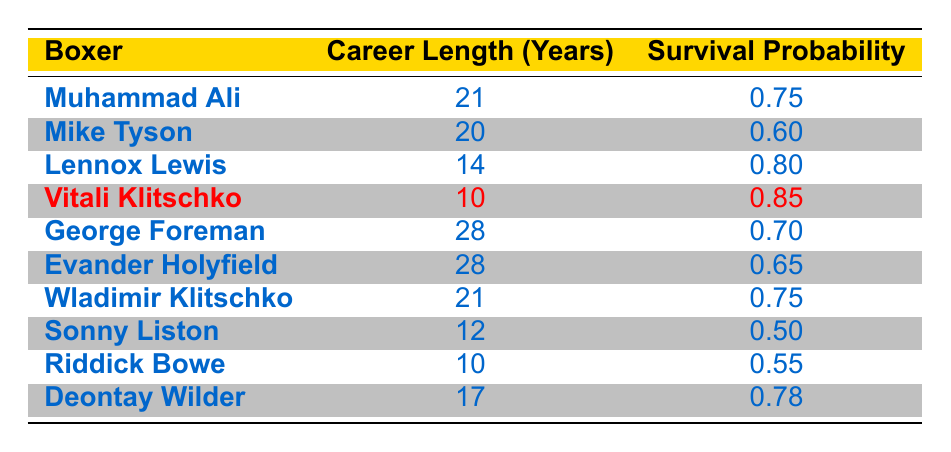What is the survival probability for Vitali Klitschko? The table indicates that Vitali Klitschko has a survival probability of 0.85, as recorded in the corresponding row.
Answer: 0.85 Which boxer has the longest career length? By scanning the table, George Foreman and Evander Holyfield both have the longest career length of 28 years.
Answer: George Foreman and Evander Holyfield What is the survival probability for boxers with a career length of 10 years? The table shows that both Vitali Klitschko and Riddick Bowe have a career length of 10 years, with survival probabilities of 0.85 and 0.55, respectively.
Answer: Vitali Klitschko: 0.85, Riddick Bowe: 0.55 Is the survival probability for Lennox Lewis greater than that of Mike Tyson? The table shows that Lennox Lewis has a survival probability of 0.80, while Mike Tyson has 0.60. Thus, Lennox Lewis's probability is greater.
Answer: Yes What is the average survival probability of the boxers listed? First, we sum all the survival probabilities: 0.75 + 0.60 + 0.80 + 0.85 + 0.70 + 0.65 + 0.75 + 0.50 + 0.55 + 0.78 = 7.65. Then, we divide by the number of boxers, which is 10. Thus, the average survival probability is 7.65 / 10 = 0.765.
Answer: 0.765 Who has a higher survival probability, Wladimir Klitschko or Deontay Wilder? Wladimir Klitschko has a survival probability of 0.75, while Deontay Wilder has a probability of 0.78. Therefore, Deontay Wilder has the higher survival probability.
Answer: Deontay Wilder How many boxers have a survival probability of less than 0.60? By reviewing the table, only Sonny Liston and Mike Tyson have survival probabilities (0.50 and 0.60, respectively) that are less than 0.60.
Answer: 1 (Sonny Liston) What is the difference in survival probabilities between Muhammad Ali and George Foreman? Muhammad Ali’s survival probability is 0.75, and George Foreman’s is 0.70. The difference is 0.75 - 0.70 = 0.05.
Answer: 0.05 